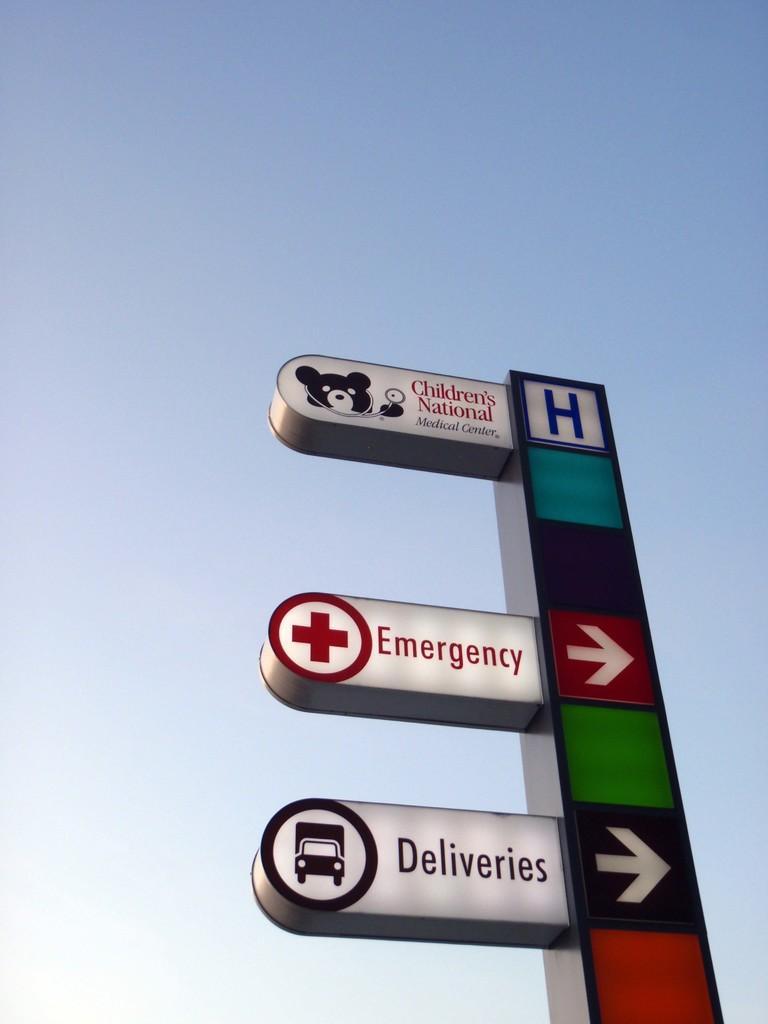Describe this image in one or two sentences. In this image I can see few boards in multi color and the sky is in blue and white color. 